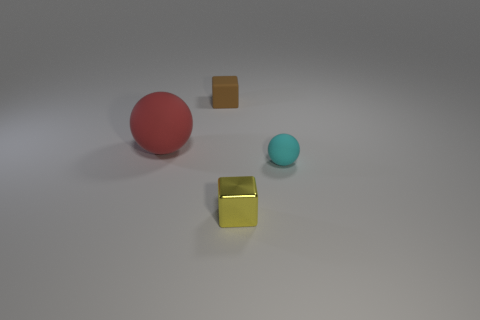How would you describe the surface on which the objects are placed? The objects appear to be rest on a smooth, matte surface. It has a neutral, light color that offers a subtle contrast with the objects, allowing their colors to stand out. The evenness of the shadows also indicates the flatness of the surface. 